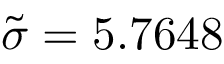<formula> <loc_0><loc_0><loc_500><loc_500>\tilde { \sigma } = 5 . 7 6 4 8</formula> 